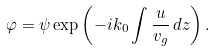Convert formula to latex. <formula><loc_0><loc_0><loc_500><loc_500>\varphi = \psi \exp \left ( - i k _ { 0 } \int \frac { u } { v _ { g } } \, d z \right ) .</formula> 